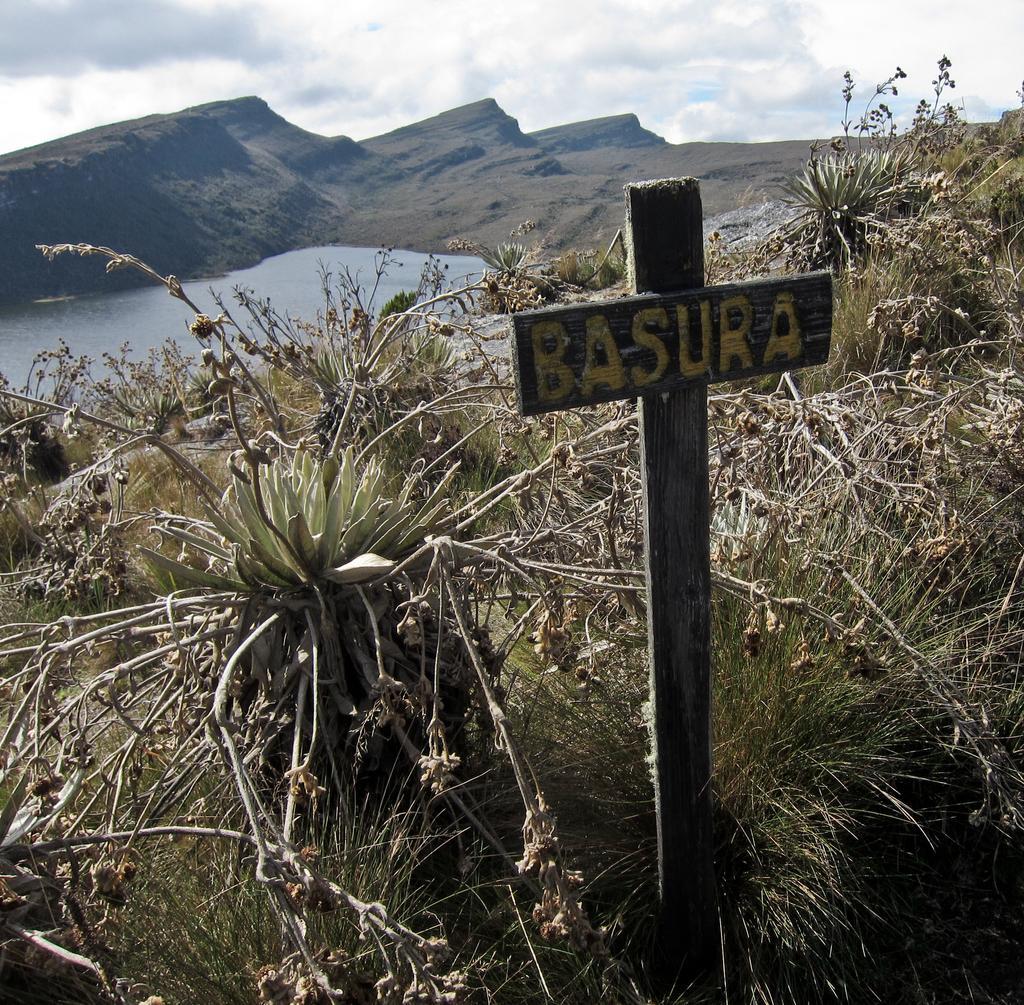Describe this image in one or two sentences. On the right side, there is a text on a wooden cross. This wooden cross on the ground, on which there are plants and grass. In the background, there is water, there are mountains and there are clouds in the sky. 